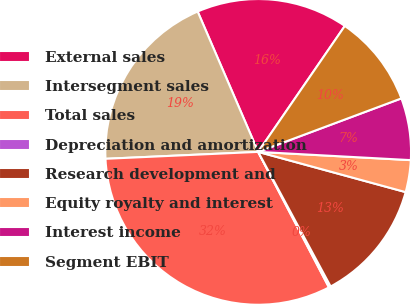Convert chart to OTSL. <chart><loc_0><loc_0><loc_500><loc_500><pie_chart><fcel>External sales<fcel>Intersegment sales<fcel>Total sales<fcel>Depreciation and amortization<fcel>Research development and<fcel>Equity royalty and interest<fcel>Interest income<fcel>Segment EBIT<nl><fcel>16.07%<fcel>19.24%<fcel>31.94%<fcel>0.2%<fcel>12.9%<fcel>3.38%<fcel>6.55%<fcel>9.72%<nl></chart> 